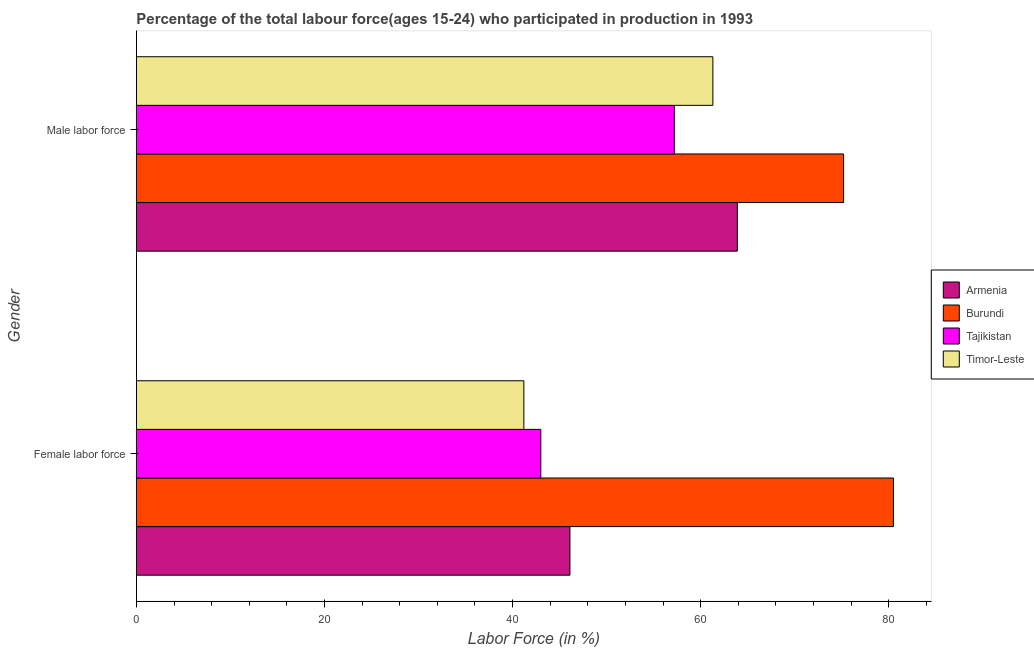How many different coloured bars are there?
Your answer should be compact. 4. How many groups of bars are there?
Provide a short and direct response. 2. How many bars are there on the 2nd tick from the bottom?
Provide a succinct answer. 4. What is the label of the 2nd group of bars from the top?
Provide a succinct answer. Female labor force. What is the percentage of female labor force in Burundi?
Provide a succinct answer. 80.5. Across all countries, what is the maximum percentage of female labor force?
Make the answer very short. 80.5. Across all countries, what is the minimum percentage of male labour force?
Provide a short and direct response. 57.2. In which country was the percentage of female labor force maximum?
Your answer should be compact. Burundi. In which country was the percentage of female labor force minimum?
Your answer should be very brief. Timor-Leste. What is the total percentage of male labour force in the graph?
Your response must be concise. 257.6. What is the difference between the percentage of female labor force in Burundi and that in Armenia?
Your answer should be very brief. 34.4. What is the difference between the percentage of male labour force in Burundi and the percentage of female labor force in Tajikistan?
Make the answer very short. 32.2. What is the average percentage of female labor force per country?
Your answer should be compact. 52.7. What is the difference between the percentage of male labour force and percentage of female labor force in Tajikistan?
Offer a very short reply. 14.2. In how many countries, is the percentage of male labour force greater than 20 %?
Provide a succinct answer. 4. What is the ratio of the percentage of male labour force in Burundi to that in Tajikistan?
Offer a very short reply. 1.31. Is the percentage of male labour force in Tajikistan less than that in Timor-Leste?
Keep it short and to the point. Yes. What does the 1st bar from the top in Female labor force represents?
Keep it short and to the point. Timor-Leste. What does the 1st bar from the bottom in Male labor force represents?
Provide a short and direct response. Armenia. Are all the bars in the graph horizontal?
Your response must be concise. Yes. Are the values on the major ticks of X-axis written in scientific E-notation?
Keep it short and to the point. No. Does the graph contain any zero values?
Your answer should be compact. No. How many legend labels are there?
Give a very brief answer. 4. What is the title of the graph?
Offer a terse response. Percentage of the total labour force(ages 15-24) who participated in production in 1993. What is the label or title of the Y-axis?
Your answer should be compact. Gender. What is the Labor Force (in %) of Armenia in Female labor force?
Your response must be concise. 46.1. What is the Labor Force (in %) of Burundi in Female labor force?
Offer a terse response. 80.5. What is the Labor Force (in %) of Tajikistan in Female labor force?
Provide a short and direct response. 43. What is the Labor Force (in %) of Timor-Leste in Female labor force?
Provide a short and direct response. 41.2. What is the Labor Force (in %) in Armenia in Male labor force?
Provide a succinct answer. 63.9. What is the Labor Force (in %) of Burundi in Male labor force?
Keep it short and to the point. 75.2. What is the Labor Force (in %) in Tajikistan in Male labor force?
Make the answer very short. 57.2. What is the Labor Force (in %) in Timor-Leste in Male labor force?
Offer a terse response. 61.3. Across all Gender, what is the maximum Labor Force (in %) of Armenia?
Keep it short and to the point. 63.9. Across all Gender, what is the maximum Labor Force (in %) of Burundi?
Make the answer very short. 80.5. Across all Gender, what is the maximum Labor Force (in %) in Tajikistan?
Offer a very short reply. 57.2. Across all Gender, what is the maximum Labor Force (in %) of Timor-Leste?
Make the answer very short. 61.3. Across all Gender, what is the minimum Labor Force (in %) in Armenia?
Provide a short and direct response. 46.1. Across all Gender, what is the minimum Labor Force (in %) of Burundi?
Your answer should be compact. 75.2. Across all Gender, what is the minimum Labor Force (in %) in Tajikistan?
Ensure brevity in your answer.  43. Across all Gender, what is the minimum Labor Force (in %) of Timor-Leste?
Provide a succinct answer. 41.2. What is the total Labor Force (in %) of Armenia in the graph?
Your answer should be compact. 110. What is the total Labor Force (in %) in Burundi in the graph?
Your answer should be compact. 155.7. What is the total Labor Force (in %) in Tajikistan in the graph?
Ensure brevity in your answer.  100.2. What is the total Labor Force (in %) in Timor-Leste in the graph?
Give a very brief answer. 102.5. What is the difference between the Labor Force (in %) in Armenia in Female labor force and that in Male labor force?
Keep it short and to the point. -17.8. What is the difference between the Labor Force (in %) of Timor-Leste in Female labor force and that in Male labor force?
Give a very brief answer. -20.1. What is the difference between the Labor Force (in %) of Armenia in Female labor force and the Labor Force (in %) of Burundi in Male labor force?
Your response must be concise. -29.1. What is the difference between the Labor Force (in %) of Armenia in Female labor force and the Labor Force (in %) of Tajikistan in Male labor force?
Provide a short and direct response. -11.1. What is the difference between the Labor Force (in %) in Armenia in Female labor force and the Labor Force (in %) in Timor-Leste in Male labor force?
Provide a short and direct response. -15.2. What is the difference between the Labor Force (in %) of Burundi in Female labor force and the Labor Force (in %) of Tajikistan in Male labor force?
Keep it short and to the point. 23.3. What is the difference between the Labor Force (in %) of Burundi in Female labor force and the Labor Force (in %) of Timor-Leste in Male labor force?
Your response must be concise. 19.2. What is the difference between the Labor Force (in %) in Tajikistan in Female labor force and the Labor Force (in %) in Timor-Leste in Male labor force?
Provide a succinct answer. -18.3. What is the average Labor Force (in %) in Armenia per Gender?
Ensure brevity in your answer.  55. What is the average Labor Force (in %) of Burundi per Gender?
Give a very brief answer. 77.85. What is the average Labor Force (in %) of Tajikistan per Gender?
Your answer should be very brief. 50.1. What is the average Labor Force (in %) of Timor-Leste per Gender?
Your answer should be very brief. 51.25. What is the difference between the Labor Force (in %) in Armenia and Labor Force (in %) in Burundi in Female labor force?
Ensure brevity in your answer.  -34.4. What is the difference between the Labor Force (in %) in Armenia and Labor Force (in %) in Tajikistan in Female labor force?
Your answer should be compact. 3.1. What is the difference between the Labor Force (in %) in Armenia and Labor Force (in %) in Timor-Leste in Female labor force?
Give a very brief answer. 4.9. What is the difference between the Labor Force (in %) in Burundi and Labor Force (in %) in Tajikistan in Female labor force?
Keep it short and to the point. 37.5. What is the difference between the Labor Force (in %) of Burundi and Labor Force (in %) of Timor-Leste in Female labor force?
Keep it short and to the point. 39.3. What is the difference between the Labor Force (in %) of Tajikistan and Labor Force (in %) of Timor-Leste in Female labor force?
Make the answer very short. 1.8. What is the difference between the Labor Force (in %) of Burundi and Labor Force (in %) of Tajikistan in Male labor force?
Provide a short and direct response. 18. What is the difference between the Labor Force (in %) in Burundi and Labor Force (in %) in Timor-Leste in Male labor force?
Provide a succinct answer. 13.9. What is the ratio of the Labor Force (in %) of Armenia in Female labor force to that in Male labor force?
Provide a succinct answer. 0.72. What is the ratio of the Labor Force (in %) in Burundi in Female labor force to that in Male labor force?
Make the answer very short. 1.07. What is the ratio of the Labor Force (in %) of Tajikistan in Female labor force to that in Male labor force?
Your answer should be very brief. 0.75. What is the ratio of the Labor Force (in %) in Timor-Leste in Female labor force to that in Male labor force?
Offer a terse response. 0.67. What is the difference between the highest and the second highest Labor Force (in %) of Tajikistan?
Offer a terse response. 14.2. What is the difference between the highest and the second highest Labor Force (in %) of Timor-Leste?
Keep it short and to the point. 20.1. What is the difference between the highest and the lowest Labor Force (in %) of Armenia?
Offer a terse response. 17.8. What is the difference between the highest and the lowest Labor Force (in %) in Burundi?
Give a very brief answer. 5.3. What is the difference between the highest and the lowest Labor Force (in %) in Tajikistan?
Make the answer very short. 14.2. What is the difference between the highest and the lowest Labor Force (in %) in Timor-Leste?
Offer a very short reply. 20.1. 